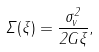<formula> <loc_0><loc_0><loc_500><loc_500>\Sigma ( \xi ) = \frac { \sigma _ { v } ^ { 2 } } { 2 G \xi } ,</formula> 